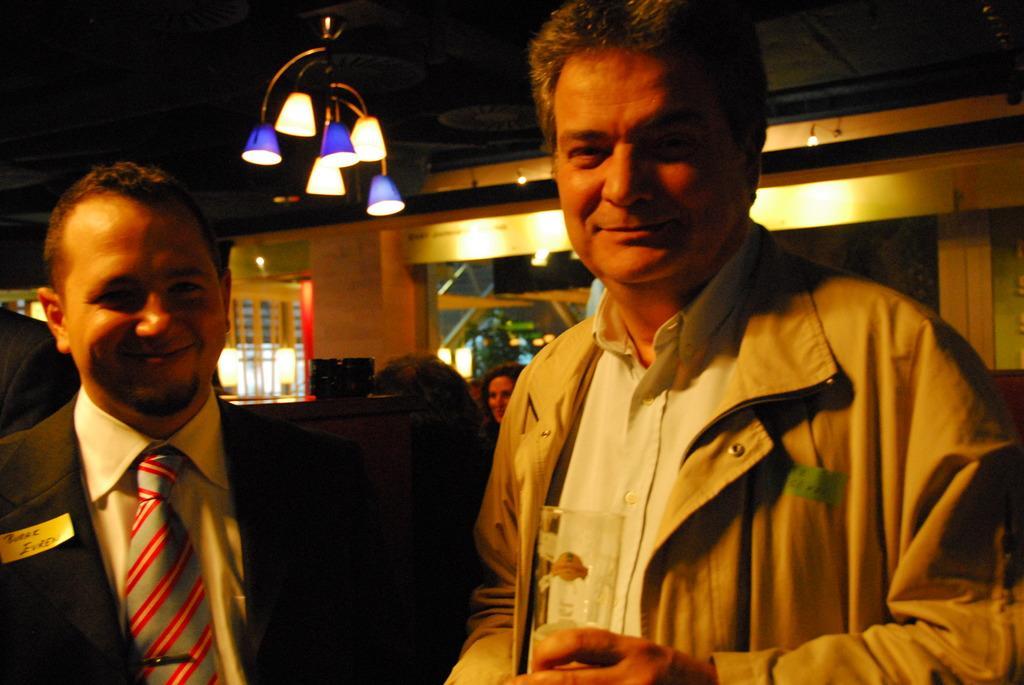Describe this image in one or two sentences. In the image there are two persons in jackets standing in the front and smiling and behind there are few persons visible and above there are lights over the ceiling. 